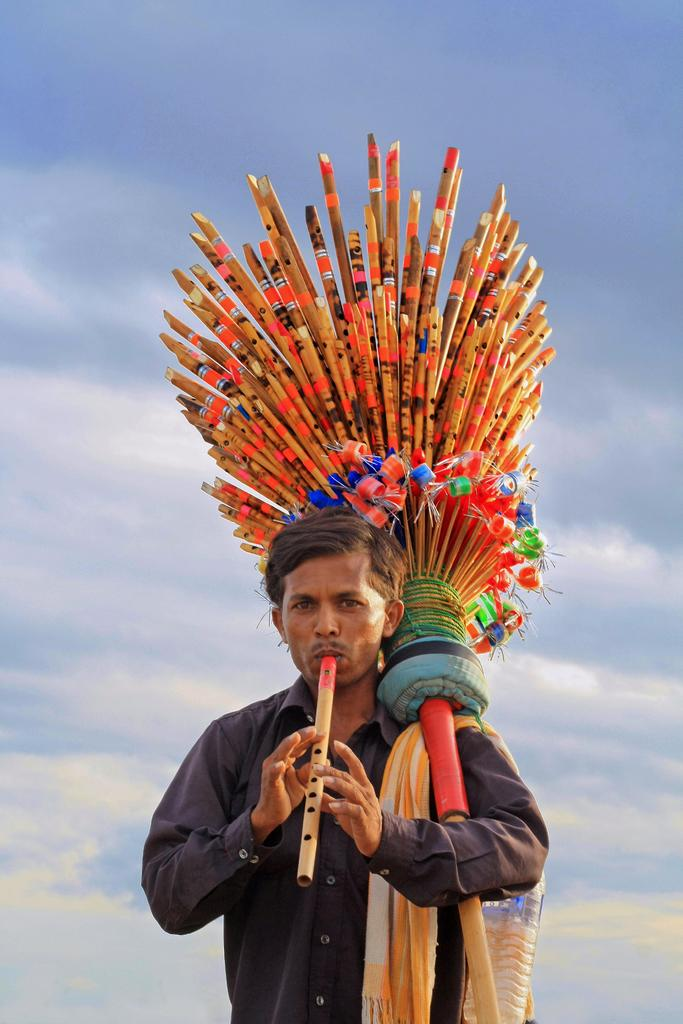What is the man in the image doing? The man is playing a flute. What else can be seen in the man's possession in the image? The man is carrying a bunch of flutes. What is the color and condition of the sky in the image? The sky is blue and cloudy in the image. Who is the owner of the dock in the image? There is no dock present in the image. How is the glue being used in the image? There is no glue present in the image. 